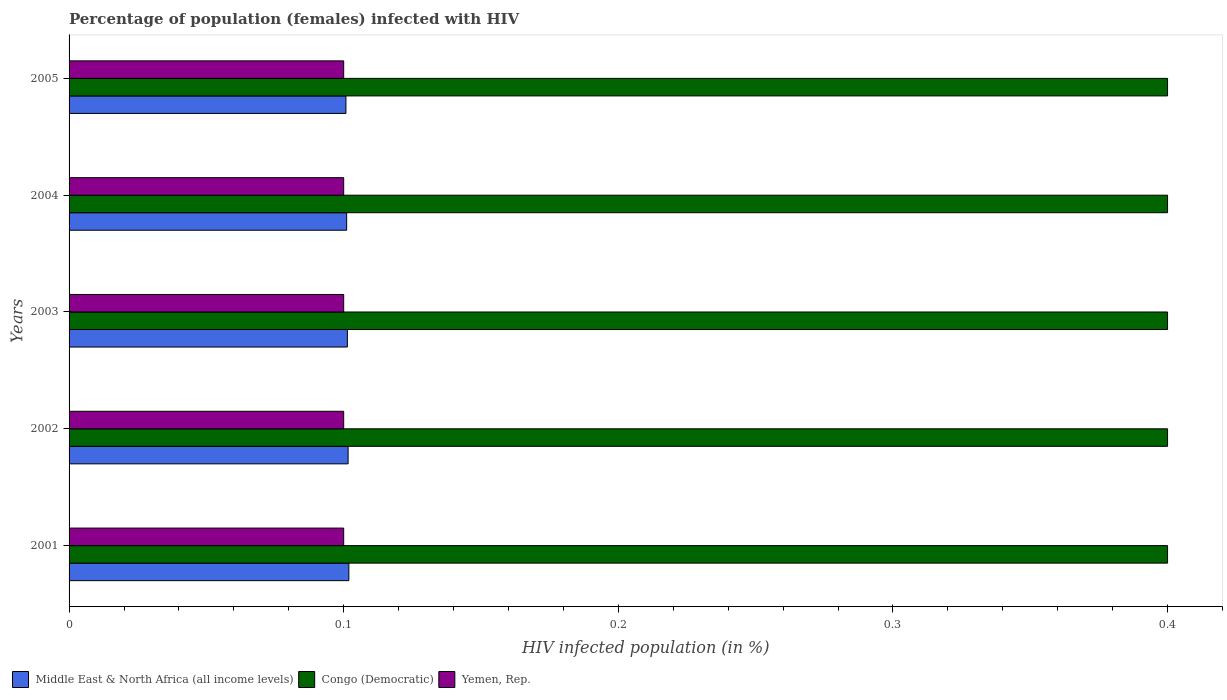How many different coloured bars are there?
Provide a succinct answer. 3. Are the number of bars per tick equal to the number of legend labels?
Make the answer very short. Yes. Are the number of bars on each tick of the Y-axis equal?
Provide a succinct answer. Yes. How many bars are there on the 2nd tick from the top?
Your response must be concise. 3. What is the label of the 3rd group of bars from the top?
Give a very brief answer. 2003. In how many cases, is the number of bars for a given year not equal to the number of legend labels?
Give a very brief answer. 0. What is the percentage of HIV infected female population in Yemen, Rep. in 2002?
Your response must be concise. 0.1. Across all years, what is the maximum percentage of HIV infected female population in Yemen, Rep.?
Keep it short and to the point. 0.1. Across all years, what is the minimum percentage of HIV infected female population in Middle East & North Africa (all income levels)?
Keep it short and to the point. 0.1. In which year was the percentage of HIV infected female population in Congo (Democratic) minimum?
Keep it short and to the point. 2001. What is the difference between the percentage of HIV infected female population in Yemen, Rep. in 2001 and that in 2002?
Ensure brevity in your answer.  0. What is the difference between the percentage of HIV infected female population in Middle East & North Africa (all income levels) in 2005 and the percentage of HIV infected female population in Yemen, Rep. in 2003?
Your answer should be very brief. 0. In the year 2005, what is the difference between the percentage of HIV infected female population in Middle East & North Africa (all income levels) and percentage of HIV infected female population in Yemen, Rep.?
Give a very brief answer. 0. In how many years, is the percentage of HIV infected female population in Yemen, Rep. greater than 0.1 %?
Provide a succinct answer. 0. What is the difference between the highest and the second highest percentage of HIV infected female population in Middle East & North Africa (all income levels)?
Ensure brevity in your answer.  0. What is the difference between the highest and the lowest percentage of HIV infected female population in Middle East & North Africa (all income levels)?
Give a very brief answer. 0. In how many years, is the percentage of HIV infected female population in Congo (Democratic) greater than the average percentage of HIV infected female population in Congo (Democratic) taken over all years?
Ensure brevity in your answer.  0. What does the 1st bar from the top in 2001 represents?
Your answer should be compact. Yemen, Rep. What does the 3rd bar from the bottom in 2003 represents?
Offer a very short reply. Yemen, Rep. How many bars are there?
Ensure brevity in your answer.  15. Are all the bars in the graph horizontal?
Your answer should be very brief. Yes. What is the difference between two consecutive major ticks on the X-axis?
Offer a terse response. 0.1. Does the graph contain any zero values?
Your response must be concise. No. How many legend labels are there?
Make the answer very short. 3. How are the legend labels stacked?
Provide a short and direct response. Horizontal. What is the title of the graph?
Ensure brevity in your answer.  Percentage of population (females) infected with HIV. Does "Kuwait" appear as one of the legend labels in the graph?
Your answer should be compact. No. What is the label or title of the X-axis?
Provide a short and direct response. HIV infected population (in %). What is the HIV infected population (in %) of Middle East & North Africa (all income levels) in 2001?
Keep it short and to the point. 0.1. What is the HIV infected population (in %) in Middle East & North Africa (all income levels) in 2002?
Your answer should be very brief. 0.1. What is the HIV infected population (in %) of Congo (Democratic) in 2002?
Provide a short and direct response. 0.4. What is the HIV infected population (in %) of Yemen, Rep. in 2002?
Offer a terse response. 0.1. What is the HIV infected population (in %) in Middle East & North Africa (all income levels) in 2003?
Offer a terse response. 0.1. What is the HIV infected population (in %) in Yemen, Rep. in 2003?
Your answer should be compact. 0.1. What is the HIV infected population (in %) in Middle East & North Africa (all income levels) in 2004?
Provide a succinct answer. 0.1. What is the HIV infected population (in %) of Congo (Democratic) in 2004?
Ensure brevity in your answer.  0.4. What is the HIV infected population (in %) in Yemen, Rep. in 2004?
Offer a terse response. 0.1. What is the HIV infected population (in %) in Middle East & North Africa (all income levels) in 2005?
Provide a short and direct response. 0.1. What is the HIV infected population (in %) in Congo (Democratic) in 2005?
Make the answer very short. 0.4. What is the HIV infected population (in %) in Yemen, Rep. in 2005?
Give a very brief answer. 0.1. Across all years, what is the maximum HIV infected population (in %) in Middle East & North Africa (all income levels)?
Offer a very short reply. 0.1. Across all years, what is the minimum HIV infected population (in %) of Middle East & North Africa (all income levels)?
Ensure brevity in your answer.  0.1. Across all years, what is the minimum HIV infected population (in %) of Yemen, Rep.?
Make the answer very short. 0.1. What is the total HIV infected population (in %) of Middle East & North Africa (all income levels) in the graph?
Your answer should be very brief. 0.51. What is the total HIV infected population (in %) in Congo (Democratic) in the graph?
Ensure brevity in your answer.  2. What is the total HIV infected population (in %) in Yemen, Rep. in the graph?
Make the answer very short. 0.5. What is the difference between the HIV infected population (in %) in Congo (Democratic) in 2001 and that in 2002?
Ensure brevity in your answer.  0. What is the difference between the HIV infected population (in %) of Middle East & North Africa (all income levels) in 2001 and that in 2003?
Your response must be concise. 0. What is the difference between the HIV infected population (in %) in Congo (Democratic) in 2001 and that in 2003?
Offer a terse response. 0. What is the difference between the HIV infected population (in %) of Yemen, Rep. in 2001 and that in 2003?
Your answer should be compact. 0. What is the difference between the HIV infected population (in %) in Middle East & North Africa (all income levels) in 2001 and that in 2004?
Ensure brevity in your answer.  0. What is the difference between the HIV infected population (in %) of Yemen, Rep. in 2001 and that in 2004?
Give a very brief answer. 0. What is the difference between the HIV infected population (in %) of Middle East & North Africa (all income levels) in 2001 and that in 2005?
Your response must be concise. 0. What is the difference between the HIV infected population (in %) of Congo (Democratic) in 2001 and that in 2005?
Keep it short and to the point. 0. What is the difference between the HIV infected population (in %) in Yemen, Rep. in 2001 and that in 2005?
Ensure brevity in your answer.  0. What is the difference between the HIV infected population (in %) in Middle East & North Africa (all income levels) in 2002 and that in 2003?
Your response must be concise. 0. What is the difference between the HIV infected population (in %) in Middle East & North Africa (all income levels) in 2002 and that in 2004?
Give a very brief answer. 0. What is the difference between the HIV infected population (in %) in Congo (Democratic) in 2002 and that in 2004?
Offer a terse response. 0. What is the difference between the HIV infected population (in %) in Yemen, Rep. in 2002 and that in 2004?
Give a very brief answer. 0. What is the difference between the HIV infected population (in %) in Middle East & North Africa (all income levels) in 2002 and that in 2005?
Offer a very short reply. 0. What is the difference between the HIV infected population (in %) in Congo (Democratic) in 2002 and that in 2005?
Your answer should be compact. 0. What is the difference between the HIV infected population (in %) in Yemen, Rep. in 2002 and that in 2005?
Give a very brief answer. 0. What is the difference between the HIV infected population (in %) of Middle East & North Africa (all income levels) in 2003 and that in 2004?
Your answer should be compact. 0. What is the difference between the HIV infected population (in %) in Congo (Democratic) in 2003 and that in 2004?
Offer a very short reply. 0. What is the difference between the HIV infected population (in %) of Yemen, Rep. in 2003 and that in 2004?
Your answer should be very brief. 0. What is the difference between the HIV infected population (in %) in Congo (Democratic) in 2003 and that in 2005?
Provide a short and direct response. 0. What is the difference between the HIV infected population (in %) of Middle East & North Africa (all income levels) in 2004 and that in 2005?
Provide a succinct answer. 0. What is the difference between the HIV infected population (in %) in Middle East & North Africa (all income levels) in 2001 and the HIV infected population (in %) in Congo (Democratic) in 2002?
Your response must be concise. -0.3. What is the difference between the HIV infected population (in %) of Middle East & North Africa (all income levels) in 2001 and the HIV infected population (in %) of Yemen, Rep. in 2002?
Your response must be concise. 0. What is the difference between the HIV infected population (in %) of Middle East & North Africa (all income levels) in 2001 and the HIV infected population (in %) of Congo (Democratic) in 2003?
Give a very brief answer. -0.3. What is the difference between the HIV infected population (in %) of Middle East & North Africa (all income levels) in 2001 and the HIV infected population (in %) of Yemen, Rep. in 2003?
Ensure brevity in your answer.  0. What is the difference between the HIV infected population (in %) in Congo (Democratic) in 2001 and the HIV infected population (in %) in Yemen, Rep. in 2003?
Offer a terse response. 0.3. What is the difference between the HIV infected population (in %) in Middle East & North Africa (all income levels) in 2001 and the HIV infected population (in %) in Congo (Democratic) in 2004?
Your answer should be compact. -0.3. What is the difference between the HIV infected population (in %) in Middle East & North Africa (all income levels) in 2001 and the HIV infected population (in %) in Yemen, Rep. in 2004?
Your answer should be compact. 0. What is the difference between the HIV infected population (in %) of Middle East & North Africa (all income levels) in 2001 and the HIV infected population (in %) of Congo (Democratic) in 2005?
Your answer should be compact. -0.3. What is the difference between the HIV infected population (in %) in Middle East & North Africa (all income levels) in 2001 and the HIV infected population (in %) in Yemen, Rep. in 2005?
Keep it short and to the point. 0. What is the difference between the HIV infected population (in %) of Middle East & North Africa (all income levels) in 2002 and the HIV infected population (in %) of Congo (Democratic) in 2003?
Keep it short and to the point. -0.3. What is the difference between the HIV infected population (in %) of Middle East & North Africa (all income levels) in 2002 and the HIV infected population (in %) of Yemen, Rep. in 2003?
Provide a short and direct response. 0. What is the difference between the HIV infected population (in %) of Middle East & North Africa (all income levels) in 2002 and the HIV infected population (in %) of Congo (Democratic) in 2004?
Ensure brevity in your answer.  -0.3. What is the difference between the HIV infected population (in %) in Middle East & North Africa (all income levels) in 2002 and the HIV infected population (in %) in Yemen, Rep. in 2004?
Your answer should be compact. 0. What is the difference between the HIV infected population (in %) of Congo (Democratic) in 2002 and the HIV infected population (in %) of Yemen, Rep. in 2004?
Ensure brevity in your answer.  0.3. What is the difference between the HIV infected population (in %) in Middle East & North Africa (all income levels) in 2002 and the HIV infected population (in %) in Congo (Democratic) in 2005?
Give a very brief answer. -0.3. What is the difference between the HIV infected population (in %) of Middle East & North Africa (all income levels) in 2002 and the HIV infected population (in %) of Yemen, Rep. in 2005?
Your response must be concise. 0. What is the difference between the HIV infected population (in %) of Congo (Democratic) in 2002 and the HIV infected population (in %) of Yemen, Rep. in 2005?
Keep it short and to the point. 0.3. What is the difference between the HIV infected population (in %) in Middle East & North Africa (all income levels) in 2003 and the HIV infected population (in %) in Congo (Democratic) in 2004?
Give a very brief answer. -0.3. What is the difference between the HIV infected population (in %) of Middle East & North Africa (all income levels) in 2003 and the HIV infected population (in %) of Yemen, Rep. in 2004?
Ensure brevity in your answer.  0. What is the difference between the HIV infected population (in %) in Congo (Democratic) in 2003 and the HIV infected population (in %) in Yemen, Rep. in 2004?
Your answer should be compact. 0.3. What is the difference between the HIV infected population (in %) of Middle East & North Africa (all income levels) in 2003 and the HIV infected population (in %) of Congo (Democratic) in 2005?
Ensure brevity in your answer.  -0.3. What is the difference between the HIV infected population (in %) of Middle East & North Africa (all income levels) in 2003 and the HIV infected population (in %) of Yemen, Rep. in 2005?
Make the answer very short. 0. What is the difference between the HIV infected population (in %) of Congo (Democratic) in 2003 and the HIV infected population (in %) of Yemen, Rep. in 2005?
Provide a succinct answer. 0.3. What is the difference between the HIV infected population (in %) of Middle East & North Africa (all income levels) in 2004 and the HIV infected population (in %) of Congo (Democratic) in 2005?
Offer a very short reply. -0.3. What is the difference between the HIV infected population (in %) of Middle East & North Africa (all income levels) in 2004 and the HIV infected population (in %) of Yemen, Rep. in 2005?
Ensure brevity in your answer.  0. What is the difference between the HIV infected population (in %) of Congo (Democratic) in 2004 and the HIV infected population (in %) of Yemen, Rep. in 2005?
Keep it short and to the point. 0.3. What is the average HIV infected population (in %) in Middle East & North Africa (all income levels) per year?
Give a very brief answer. 0.1. In the year 2001, what is the difference between the HIV infected population (in %) of Middle East & North Africa (all income levels) and HIV infected population (in %) of Congo (Democratic)?
Your answer should be compact. -0.3. In the year 2001, what is the difference between the HIV infected population (in %) in Middle East & North Africa (all income levels) and HIV infected population (in %) in Yemen, Rep.?
Offer a terse response. 0. In the year 2001, what is the difference between the HIV infected population (in %) in Congo (Democratic) and HIV infected population (in %) in Yemen, Rep.?
Your answer should be compact. 0.3. In the year 2002, what is the difference between the HIV infected population (in %) of Middle East & North Africa (all income levels) and HIV infected population (in %) of Congo (Democratic)?
Give a very brief answer. -0.3. In the year 2002, what is the difference between the HIV infected population (in %) in Middle East & North Africa (all income levels) and HIV infected population (in %) in Yemen, Rep.?
Provide a succinct answer. 0. In the year 2002, what is the difference between the HIV infected population (in %) in Congo (Democratic) and HIV infected population (in %) in Yemen, Rep.?
Provide a short and direct response. 0.3. In the year 2003, what is the difference between the HIV infected population (in %) of Middle East & North Africa (all income levels) and HIV infected population (in %) of Congo (Democratic)?
Your answer should be very brief. -0.3. In the year 2003, what is the difference between the HIV infected population (in %) of Middle East & North Africa (all income levels) and HIV infected population (in %) of Yemen, Rep.?
Provide a short and direct response. 0. In the year 2003, what is the difference between the HIV infected population (in %) in Congo (Democratic) and HIV infected population (in %) in Yemen, Rep.?
Your answer should be very brief. 0.3. In the year 2004, what is the difference between the HIV infected population (in %) of Middle East & North Africa (all income levels) and HIV infected population (in %) of Congo (Democratic)?
Provide a succinct answer. -0.3. In the year 2004, what is the difference between the HIV infected population (in %) of Middle East & North Africa (all income levels) and HIV infected population (in %) of Yemen, Rep.?
Your response must be concise. 0. In the year 2004, what is the difference between the HIV infected population (in %) of Congo (Democratic) and HIV infected population (in %) of Yemen, Rep.?
Provide a short and direct response. 0.3. In the year 2005, what is the difference between the HIV infected population (in %) of Middle East & North Africa (all income levels) and HIV infected population (in %) of Congo (Democratic)?
Provide a succinct answer. -0.3. In the year 2005, what is the difference between the HIV infected population (in %) of Middle East & North Africa (all income levels) and HIV infected population (in %) of Yemen, Rep.?
Give a very brief answer. 0. In the year 2005, what is the difference between the HIV infected population (in %) in Congo (Democratic) and HIV infected population (in %) in Yemen, Rep.?
Provide a short and direct response. 0.3. What is the ratio of the HIV infected population (in %) of Middle East & North Africa (all income levels) in 2001 to that in 2002?
Give a very brief answer. 1. What is the ratio of the HIV infected population (in %) in Yemen, Rep. in 2001 to that in 2002?
Offer a terse response. 1. What is the ratio of the HIV infected population (in %) in Congo (Democratic) in 2001 to that in 2003?
Keep it short and to the point. 1. What is the ratio of the HIV infected population (in %) of Middle East & North Africa (all income levels) in 2001 to that in 2004?
Your answer should be very brief. 1.01. What is the ratio of the HIV infected population (in %) of Middle East & North Africa (all income levels) in 2001 to that in 2005?
Your answer should be compact. 1.01. What is the ratio of the HIV infected population (in %) in Middle East & North Africa (all income levels) in 2002 to that in 2003?
Provide a short and direct response. 1. What is the ratio of the HIV infected population (in %) in Congo (Democratic) in 2002 to that in 2003?
Give a very brief answer. 1. What is the ratio of the HIV infected population (in %) in Yemen, Rep. in 2002 to that in 2003?
Give a very brief answer. 1. What is the ratio of the HIV infected population (in %) in Middle East & North Africa (all income levels) in 2002 to that in 2004?
Offer a terse response. 1.01. What is the ratio of the HIV infected population (in %) in Yemen, Rep. in 2002 to that in 2004?
Your answer should be compact. 1. What is the ratio of the HIV infected population (in %) of Middle East & North Africa (all income levels) in 2002 to that in 2005?
Make the answer very short. 1.01. What is the ratio of the HIV infected population (in %) in Yemen, Rep. in 2002 to that in 2005?
Keep it short and to the point. 1. What is the ratio of the HIV infected population (in %) in Middle East & North Africa (all income levels) in 2003 to that in 2004?
Your answer should be compact. 1. What is the ratio of the HIV infected population (in %) in Congo (Democratic) in 2003 to that in 2004?
Offer a very short reply. 1. What is the ratio of the HIV infected population (in %) of Yemen, Rep. in 2003 to that in 2004?
Offer a terse response. 1. What is the ratio of the HIV infected population (in %) of Middle East & North Africa (all income levels) in 2004 to that in 2005?
Provide a succinct answer. 1. What is the ratio of the HIV infected population (in %) of Congo (Democratic) in 2004 to that in 2005?
Offer a very short reply. 1. What is the difference between the highest and the second highest HIV infected population (in %) in Middle East & North Africa (all income levels)?
Provide a short and direct response. 0. What is the difference between the highest and the lowest HIV infected population (in %) of Middle East & North Africa (all income levels)?
Offer a terse response. 0. What is the difference between the highest and the lowest HIV infected population (in %) of Congo (Democratic)?
Offer a terse response. 0. 